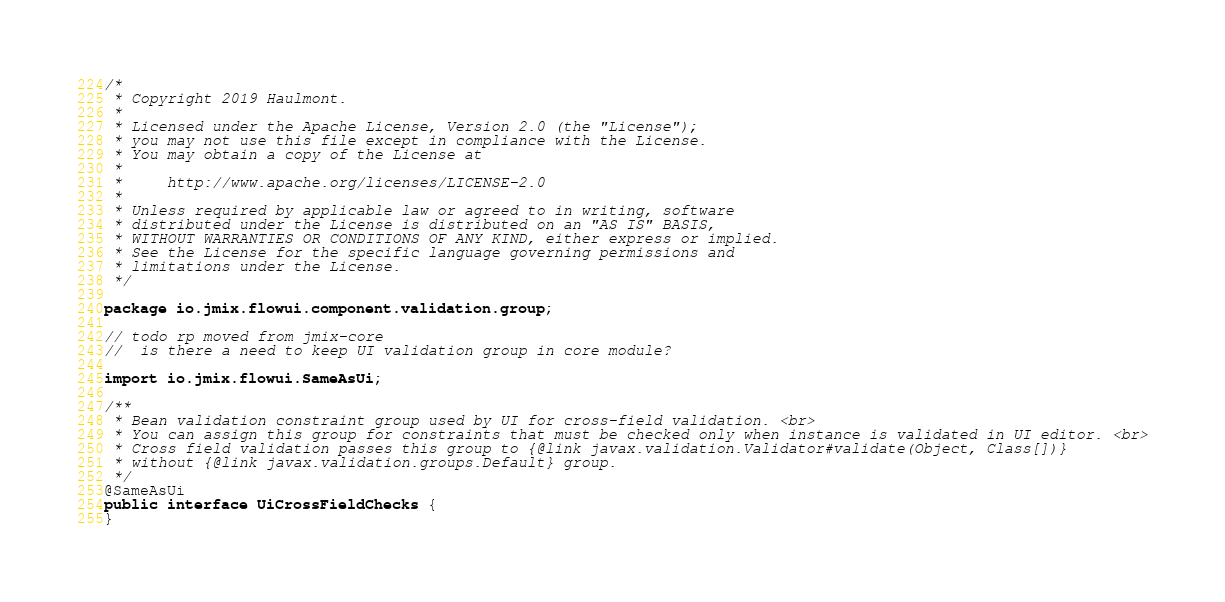<code> <loc_0><loc_0><loc_500><loc_500><_Java_>/*
 * Copyright 2019 Haulmont.
 *
 * Licensed under the Apache License, Version 2.0 (the "License");
 * you may not use this file except in compliance with the License.
 * You may obtain a copy of the License at
 *
 *     http://www.apache.org/licenses/LICENSE-2.0
 *
 * Unless required by applicable law or agreed to in writing, software
 * distributed under the License is distributed on an "AS IS" BASIS,
 * WITHOUT WARRANTIES OR CONDITIONS OF ANY KIND, either express or implied.
 * See the License for the specific language governing permissions and
 * limitations under the License.
 */

package io.jmix.flowui.component.validation.group;

// todo rp moved from jmix-core
//  is there a need to keep UI validation group in core module?

import io.jmix.flowui.SameAsUi;

/**
 * Bean validation constraint group used by UI for cross-field validation. <br>
 * You can assign this group for constraints that must be checked only when instance is validated in UI editor. <br>
 * Cross field validation passes this group to {@link javax.validation.Validator#validate(Object, Class[])}
 * without {@link javax.validation.groups.Default} group.
 */
@SameAsUi
public interface UiCrossFieldChecks {
}</code> 